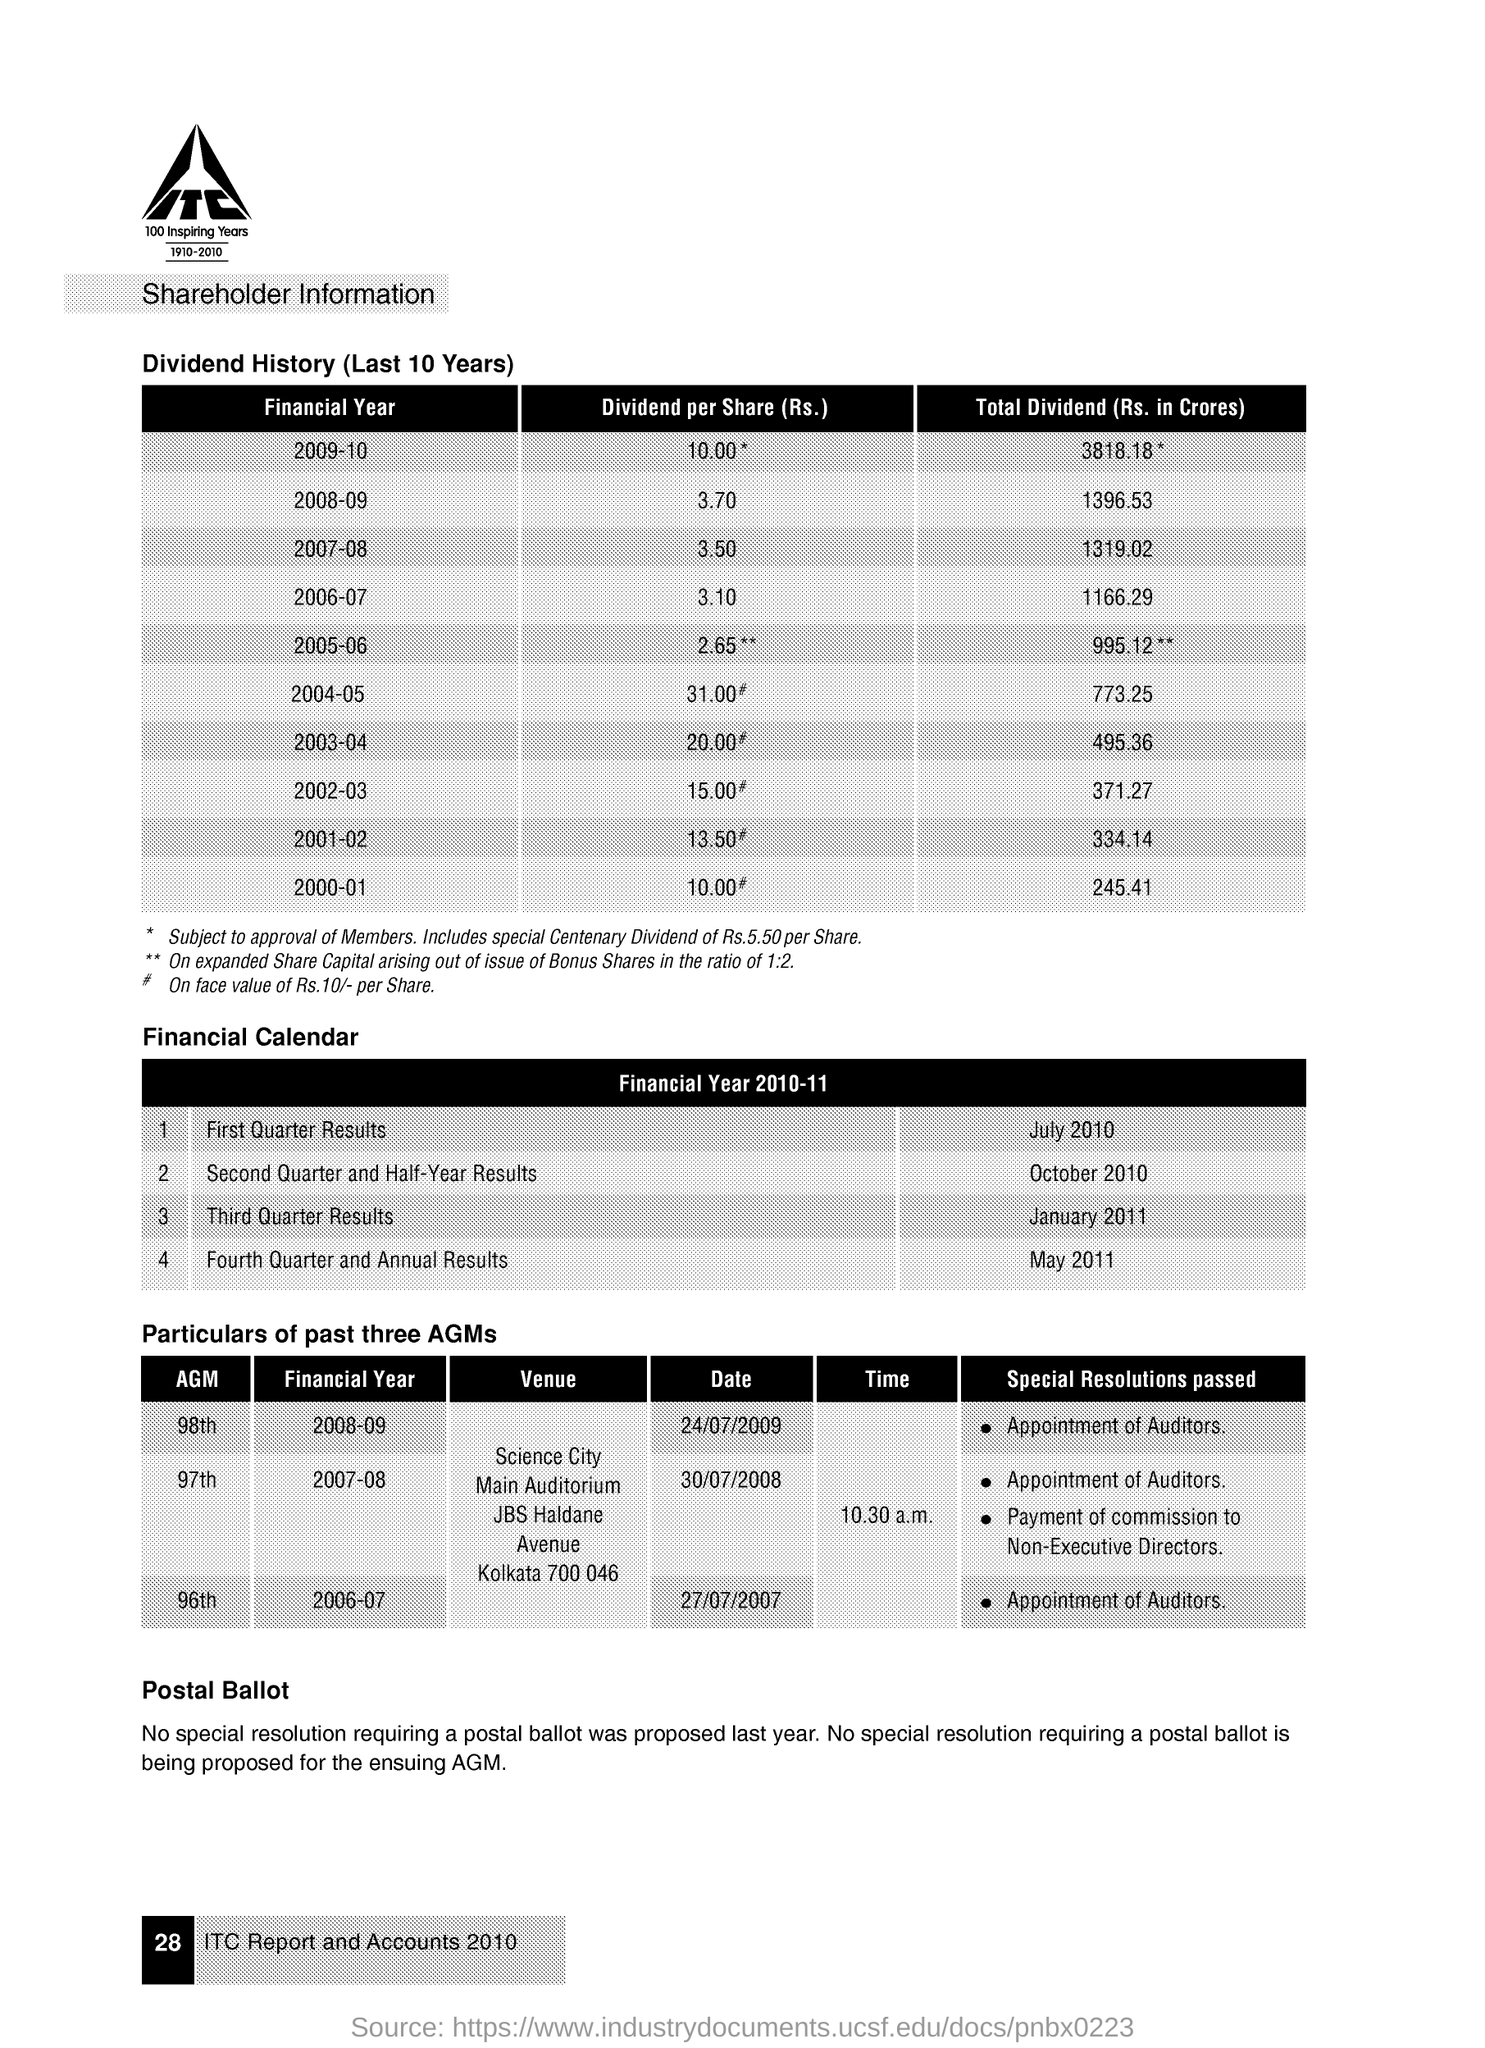Highlight a few significant elements in this photo. The 98th Annual General Meeting was conducted for the financial year 2008-09 on July 24, 2009. The total dividend for the financial year 2007-08 was 1,319.02 crores. The first quarter results for the financial year 2010-11 were announced in July 2010. The dividend per share for the financial year 2008-09 was Rs. 3.70. The total dividend for the financial year 2006-07 was 1166.29 crores. 